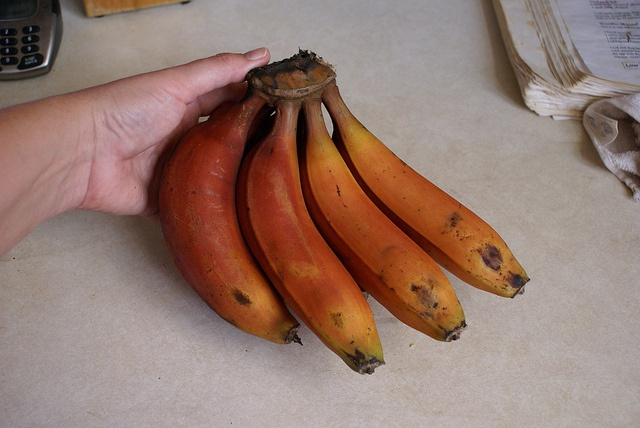Describe the objects in this image and their specific colors. I can see banana in black, brown, and maroon tones, people in black, gray, and lightpink tones, book in black and gray tones, and cell phone in black and gray tones in this image. 